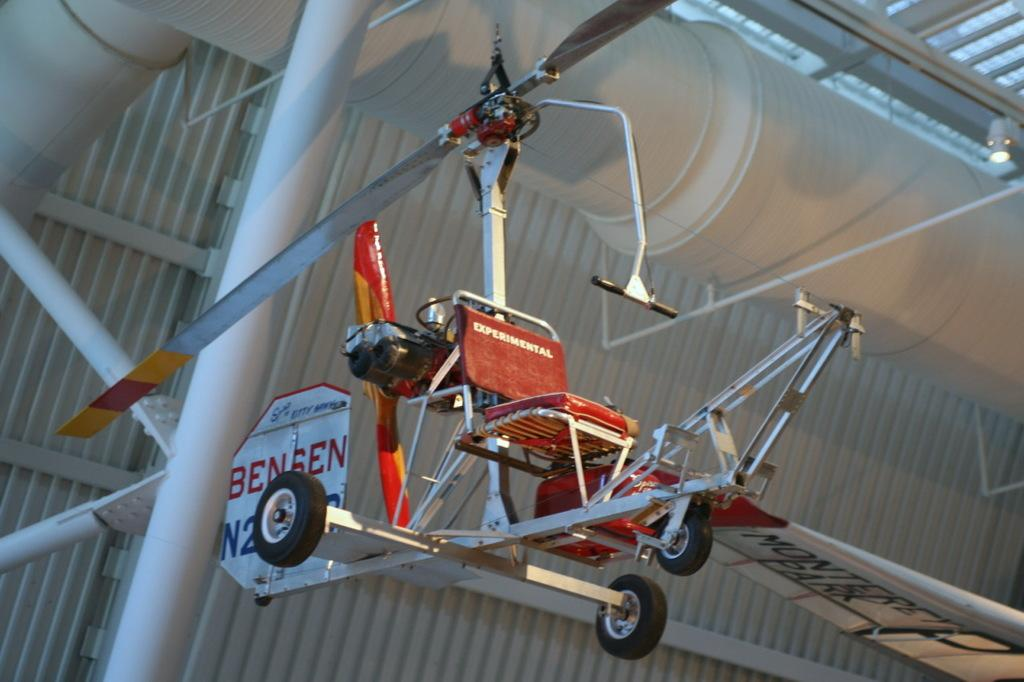What type of furniture is present in the image? There is a chair in the image. How is the chair positioned in the image? The chair is hanging from the roof. What structure is visible above the chair? There is a roof visible in the image. What can be seen behind the chair? There is a sign pole behind the chair. How many fish are swimming around the chair in the image? There are no fish present in the image. Can you describe the ant that is crawling on the sign pole in the image? There is no ant visible on the sign pole in the image. 